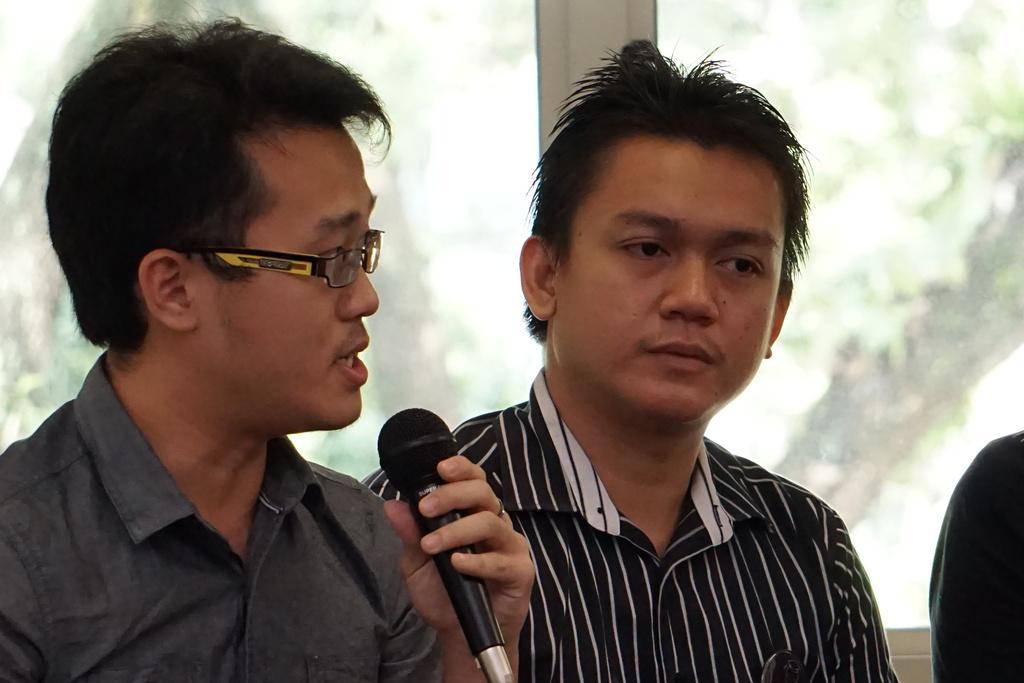Please provide a concise description of this image. In the image we can see two persons,on the left side person he is holding microphone. Coming to the background we can see the glass. 